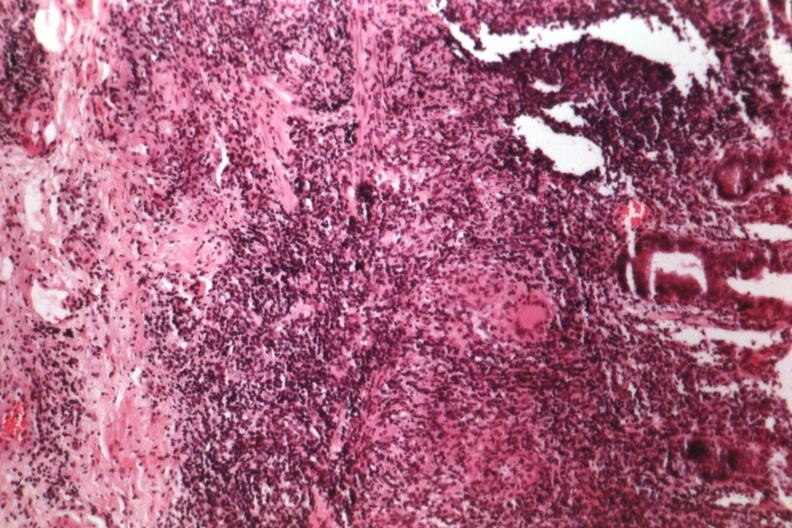s heel ulcer present?
Answer the question using a single word or phrase. No 